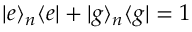<formula> <loc_0><loc_0><loc_500><loc_500>| e \rangle _ { n } \langle e | + | g \rangle _ { n } \langle g | = 1</formula> 